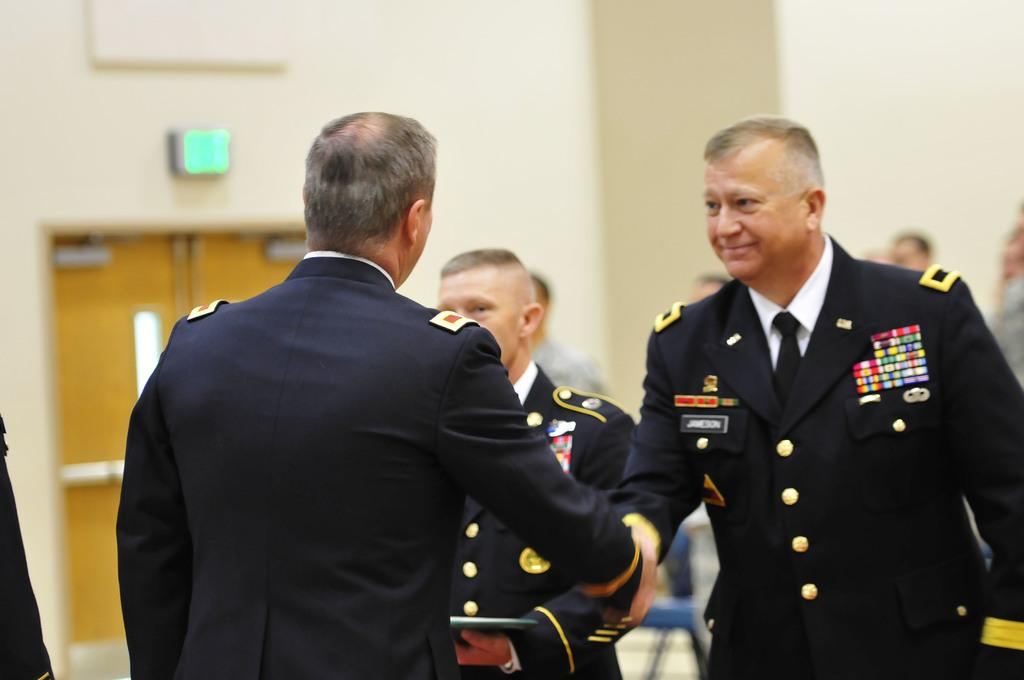How many people are in the image? There are multiple persons in the image. What color are the dresses worn by the people in the image? All the persons are wearing black-colored dresses. Can you describe the interaction between two of the persons in the image? There are two persons in the middle of the image shaking hands. How many frogs can be seen jumping on the bed in the image? There are no frogs or beds present in the image. What type of bedroom is shown in the image? There is no bedroom present in the image. 